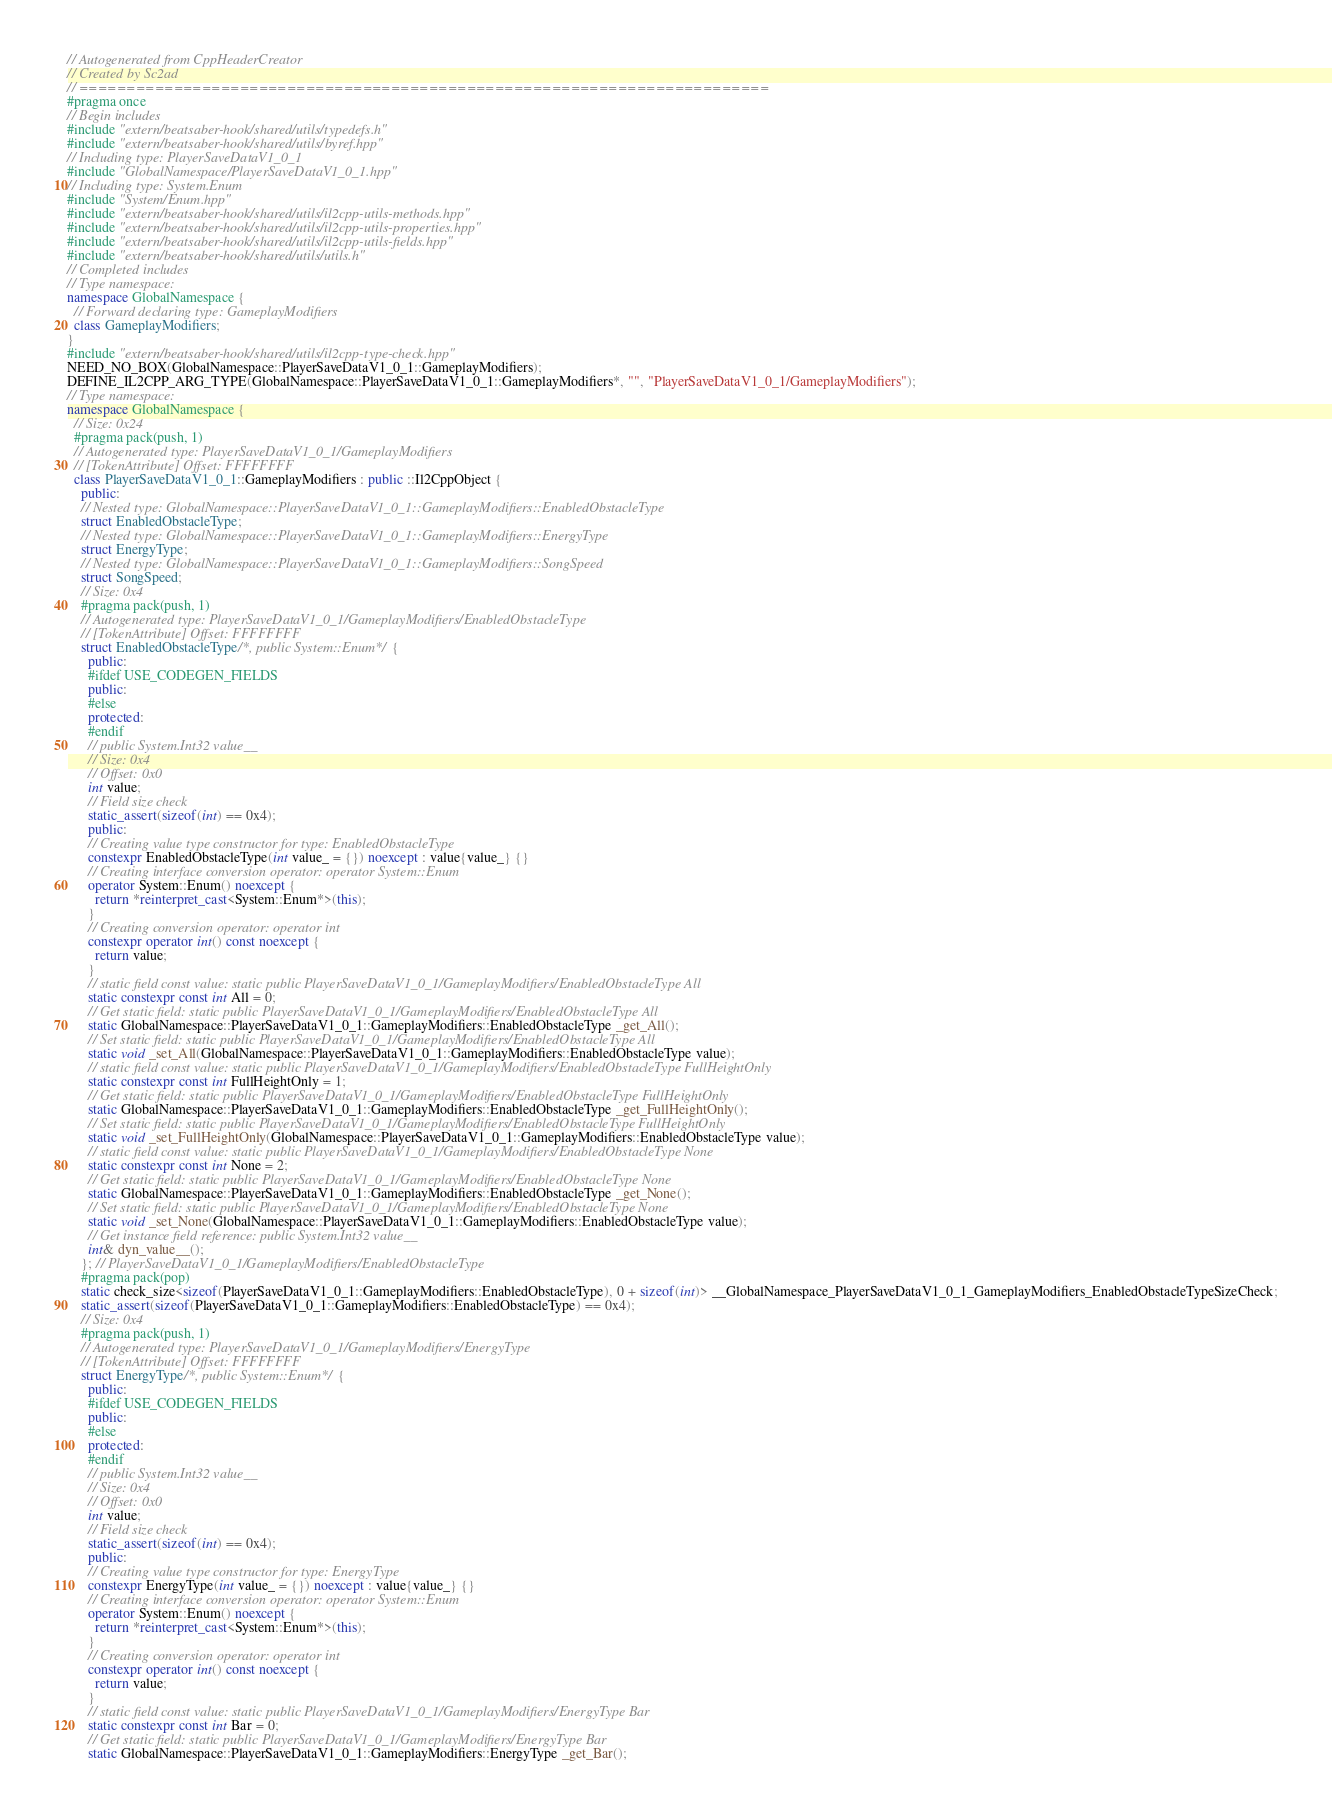Convert code to text. <code><loc_0><loc_0><loc_500><loc_500><_C++_>// Autogenerated from CppHeaderCreator
// Created by Sc2ad
// =========================================================================
#pragma once
// Begin includes
#include "extern/beatsaber-hook/shared/utils/typedefs.h"
#include "extern/beatsaber-hook/shared/utils/byref.hpp"
// Including type: PlayerSaveDataV1_0_1
#include "GlobalNamespace/PlayerSaveDataV1_0_1.hpp"
// Including type: System.Enum
#include "System/Enum.hpp"
#include "extern/beatsaber-hook/shared/utils/il2cpp-utils-methods.hpp"
#include "extern/beatsaber-hook/shared/utils/il2cpp-utils-properties.hpp"
#include "extern/beatsaber-hook/shared/utils/il2cpp-utils-fields.hpp"
#include "extern/beatsaber-hook/shared/utils/utils.h"
// Completed includes
// Type namespace: 
namespace GlobalNamespace {
  // Forward declaring type: GameplayModifiers
  class GameplayModifiers;
}
#include "extern/beatsaber-hook/shared/utils/il2cpp-type-check.hpp"
NEED_NO_BOX(GlobalNamespace::PlayerSaveDataV1_0_1::GameplayModifiers);
DEFINE_IL2CPP_ARG_TYPE(GlobalNamespace::PlayerSaveDataV1_0_1::GameplayModifiers*, "", "PlayerSaveDataV1_0_1/GameplayModifiers");
// Type namespace: 
namespace GlobalNamespace {
  // Size: 0x24
  #pragma pack(push, 1)
  // Autogenerated type: PlayerSaveDataV1_0_1/GameplayModifiers
  // [TokenAttribute] Offset: FFFFFFFF
  class PlayerSaveDataV1_0_1::GameplayModifiers : public ::Il2CppObject {
    public:
    // Nested type: GlobalNamespace::PlayerSaveDataV1_0_1::GameplayModifiers::EnabledObstacleType
    struct EnabledObstacleType;
    // Nested type: GlobalNamespace::PlayerSaveDataV1_0_1::GameplayModifiers::EnergyType
    struct EnergyType;
    // Nested type: GlobalNamespace::PlayerSaveDataV1_0_1::GameplayModifiers::SongSpeed
    struct SongSpeed;
    // Size: 0x4
    #pragma pack(push, 1)
    // Autogenerated type: PlayerSaveDataV1_0_1/GameplayModifiers/EnabledObstacleType
    // [TokenAttribute] Offset: FFFFFFFF
    struct EnabledObstacleType/*, public System::Enum*/ {
      public:
      #ifdef USE_CODEGEN_FIELDS
      public:
      #else
      protected:
      #endif
      // public System.Int32 value__
      // Size: 0x4
      // Offset: 0x0
      int value;
      // Field size check
      static_assert(sizeof(int) == 0x4);
      public:
      // Creating value type constructor for type: EnabledObstacleType
      constexpr EnabledObstacleType(int value_ = {}) noexcept : value{value_} {}
      // Creating interface conversion operator: operator System::Enum
      operator System::Enum() noexcept {
        return *reinterpret_cast<System::Enum*>(this);
      }
      // Creating conversion operator: operator int
      constexpr operator int() const noexcept {
        return value;
      }
      // static field const value: static public PlayerSaveDataV1_0_1/GameplayModifiers/EnabledObstacleType All
      static constexpr const int All = 0;
      // Get static field: static public PlayerSaveDataV1_0_1/GameplayModifiers/EnabledObstacleType All
      static GlobalNamespace::PlayerSaveDataV1_0_1::GameplayModifiers::EnabledObstacleType _get_All();
      // Set static field: static public PlayerSaveDataV1_0_1/GameplayModifiers/EnabledObstacleType All
      static void _set_All(GlobalNamespace::PlayerSaveDataV1_0_1::GameplayModifiers::EnabledObstacleType value);
      // static field const value: static public PlayerSaveDataV1_0_1/GameplayModifiers/EnabledObstacleType FullHeightOnly
      static constexpr const int FullHeightOnly = 1;
      // Get static field: static public PlayerSaveDataV1_0_1/GameplayModifiers/EnabledObstacleType FullHeightOnly
      static GlobalNamespace::PlayerSaveDataV1_0_1::GameplayModifiers::EnabledObstacleType _get_FullHeightOnly();
      // Set static field: static public PlayerSaveDataV1_0_1/GameplayModifiers/EnabledObstacleType FullHeightOnly
      static void _set_FullHeightOnly(GlobalNamespace::PlayerSaveDataV1_0_1::GameplayModifiers::EnabledObstacleType value);
      // static field const value: static public PlayerSaveDataV1_0_1/GameplayModifiers/EnabledObstacleType None
      static constexpr const int None = 2;
      // Get static field: static public PlayerSaveDataV1_0_1/GameplayModifiers/EnabledObstacleType None
      static GlobalNamespace::PlayerSaveDataV1_0_1::GameplayModifiers::EnabledObstacleType _get_None();
      // Set static field: static public PlayerSaveDataV1_0_1/GameplayModifiers/EnabledObstacleType None
      static void _set_None(GlobalNamespace::PlayerSaveDataV1_0_1::GameplayModifiers::EnabledObstacleType value);
      // Get instance field reference: public System.Int32 value__
      int& dyn_value__();
    }; // PlayerSaveDataV1_0_1/GameplayModifiers/EnabledObstacleType
    #pragma pack(pop)
    static check_size<sizeof(PlayerSaveDataV1_0_1::GameplayModifiers::EnabledObstacleType), 0 + sizeof(int)> __GlobalNamespace_PlayerSaveDataV1_0_1_GameplayModifiers_EnabledObstacleTypeSizeCheck;
    static_assert(sizeof(PlayerSaveDataV1_0_1::GameplayModifiers::EnabledObstacleType) == 0x4);
    // Size: 0x4
    #pragma pack(push, 1)
    // Autogenerated type: PlayerSaveDataV1_0_1/GameplayModifiers/EnergyType
    // [TokenAttribute] Offset: FFFFFFFF
    struct EnergyType/*, public System::Enum*/ {
      public:
      #ifdef USE_CODEGEN_FIELDS
      public:
      #else
      protected:
      #endif
      // public System.Int32 value__
      // Size: 0x4
      // Offset: 0x0
      int value;
      // Field size check
      static_assert(sizeof(int) == 0x4);
      public:
      // Creating value type constructor for type: EnergyType
      constexpr EnergyType(int value_ = {}) noexcept : value{value_} {}
      // Creating interface conversion operator: operator System::Enum
      operator System::Enum() noexcept {
        return *reinterpret_cast<System::Enum*>(this);
      }
      // Creating conversion operator: operator int
      constexpr operator int() const noexcept {
        return value;
      }
      // static field const value: static public PlayerSaveDataV1_0_1/GameplayModifiers/EnergyType Bar
      static constexpr const int Bar = 0;
      // Get static field: static public PlayerSaveDataV1_0_1/GameplayModifiers/EnergyType Bar
      static GlobalNamespace::PlayerSaveDataV1_0_1::GameplayModifiers::EnergyType _get_Bar();</code> 